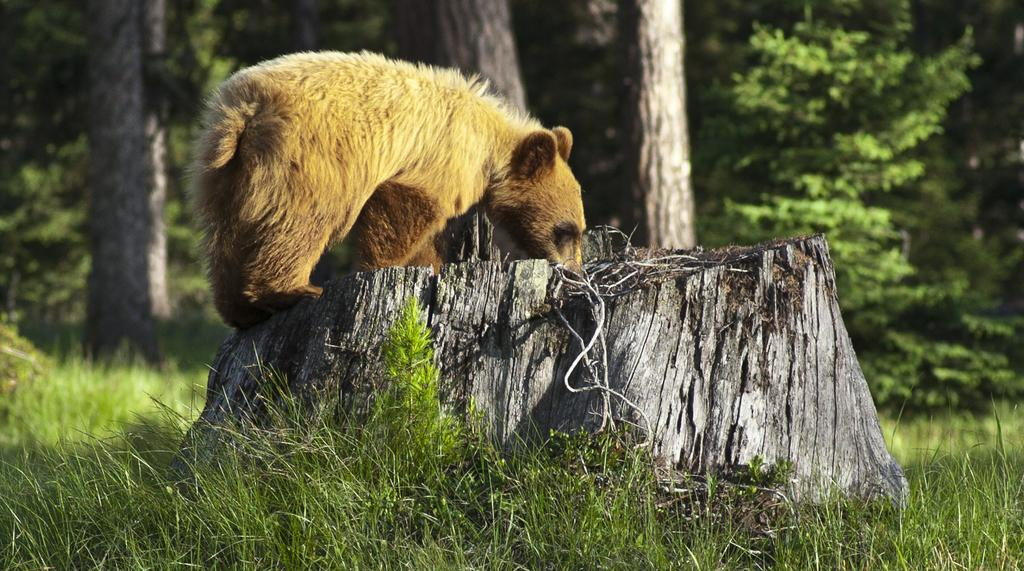What type of landscape is depicted in the image? There is a grassland in the image. What can be seen in the middle of the grassland? There is a log in the middle of the grassland. What animal is sitting on the log? There is a bear on the log. What can be seen in the background of the image? There are trees in the background of the image. What type of stove can be seen in the image? There is no stove present in the image; it features a grassland, a log, a bear, and trees. 